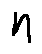<formula> <loc_0><loc_0><loc_500><loc_500>n</formula> 